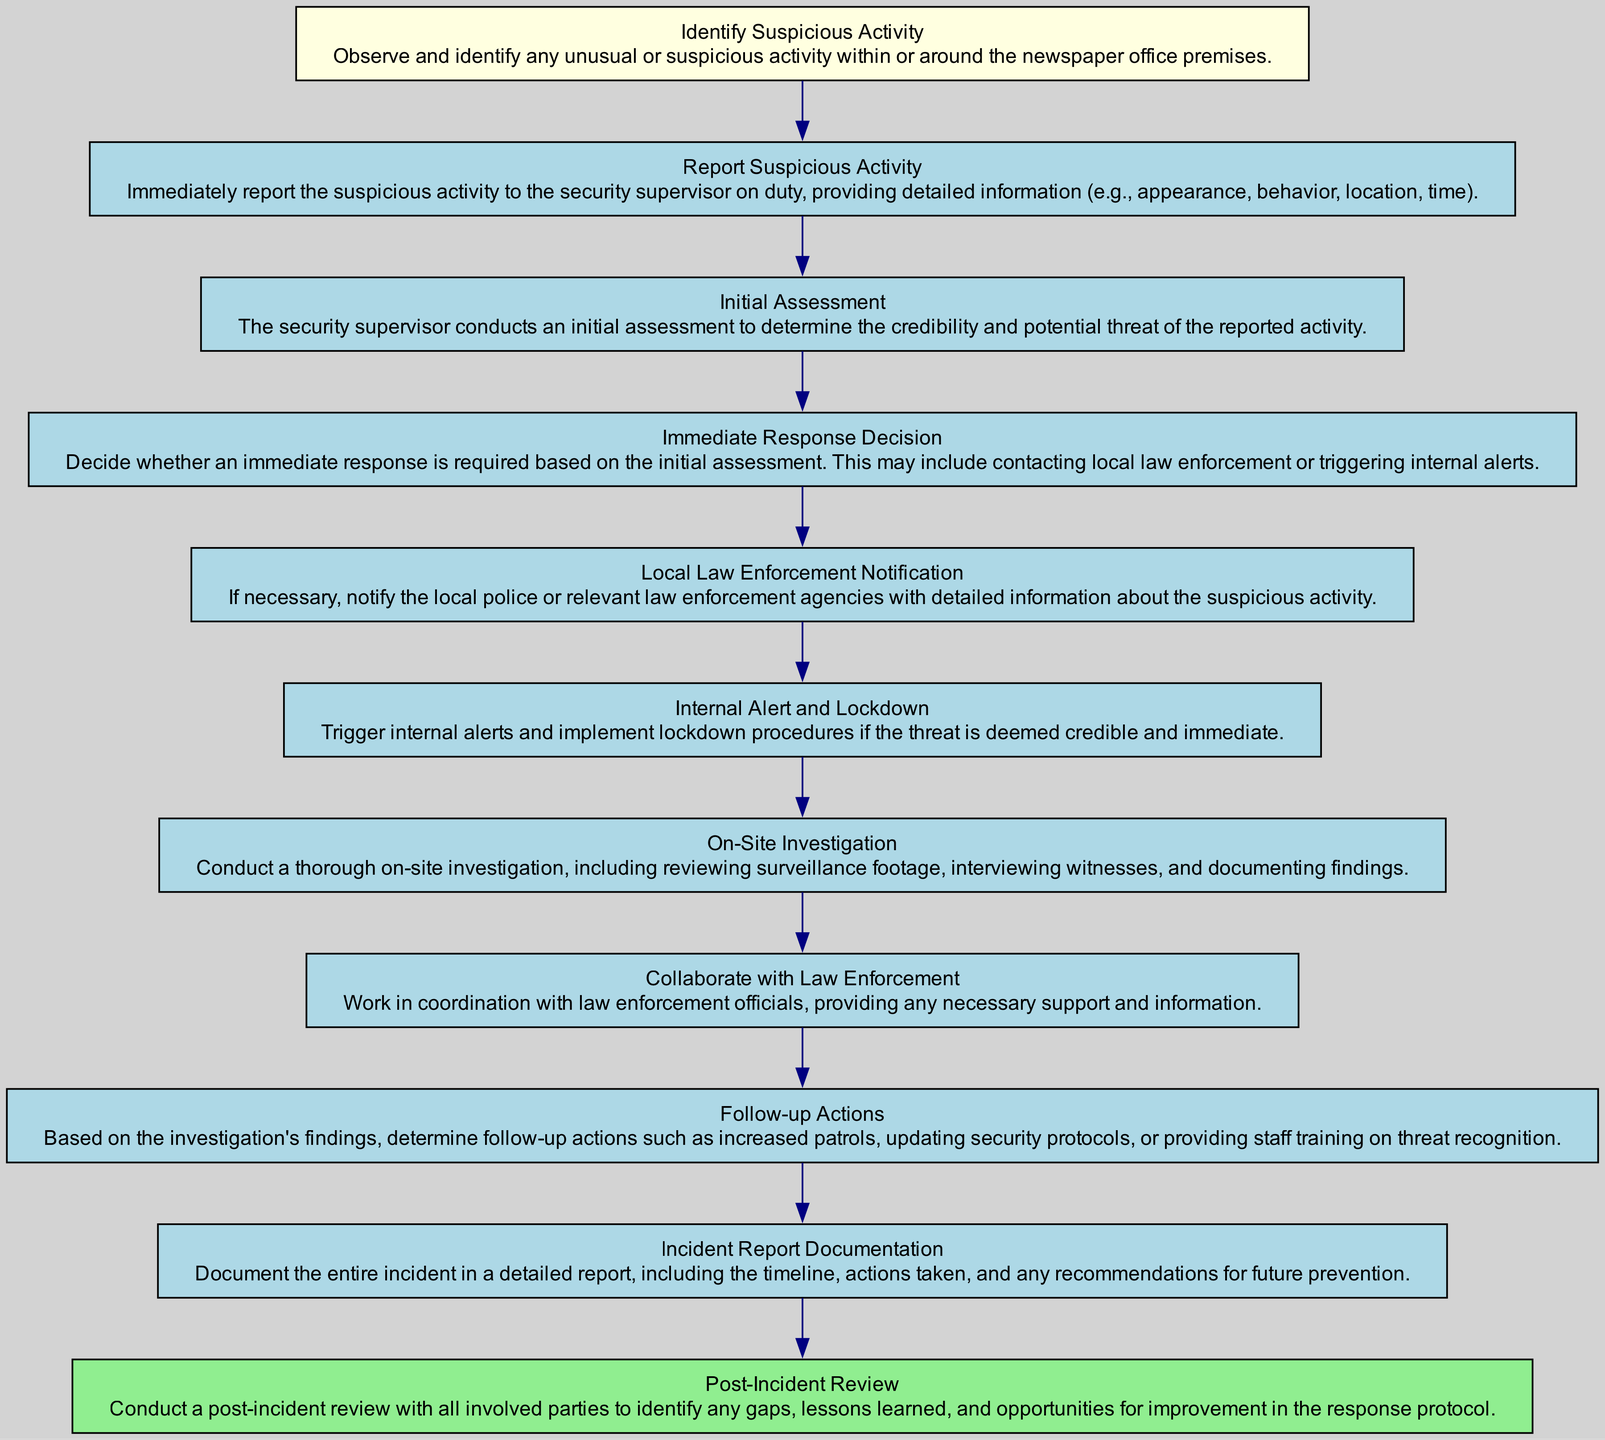What is the first step in the incident reporting protocol? The first step listed in the diagram is "Identify Suspicious Activity." This is depicted at the top of the flow chart and initiates the response protocol.
Answer: Identify Suspicious Activity How many steps are included in the protocol? By counting the nodes in the diagram, there are a total of eleven steps from "Identify Suspicious Activity" to "Post-Incident Review."
Answer: Eleven What action occurs after "Report Suspicious Activity"? Following "Report Suspicious Activity," the next step in the flow chart is "Initial Assessment," indicating that once a report is made, the security supervisor evaluates the situation.
Answer: Initial Assessment Which step leads to notifying local law enforcement? The step that leads to notifying local law enforcement is "Immediate Response Decision." After this assessment, if a threat is credible, the next step is "Local Law Enforcement Notification."
Answer: Immediate Response Decision What is the final action in the incident reporting protocol? The final action depicted in the diagram is "Post-Incident Review," which is the last step to analyze the incident and implement improvements.
Answer: Post-Incident Review What happens if the threat is deemed immediate and credible? If the threat is deemed immediate and credible, the protocol directs that "Internal Alert and Lockdown" procedures are triggered to protect the premises and personnel.
Answer: Internal Alert and Lockdown How do follow-up actions relate to on-site investigation findings? Follow-up actions occur after the "On-Site Investigation" step. The findings from the investigation inform what actions should be taken, such as adjusting security protocols or staff training.
Answer: Based on investigation findings What is documented in the "Incident Report Documentation"? In the "Incident Report Documentation," all details of the incident, including the timeline, actions taken, and recommendations, are recorded for future reference and improvement.
Answer: Document the entire incident 